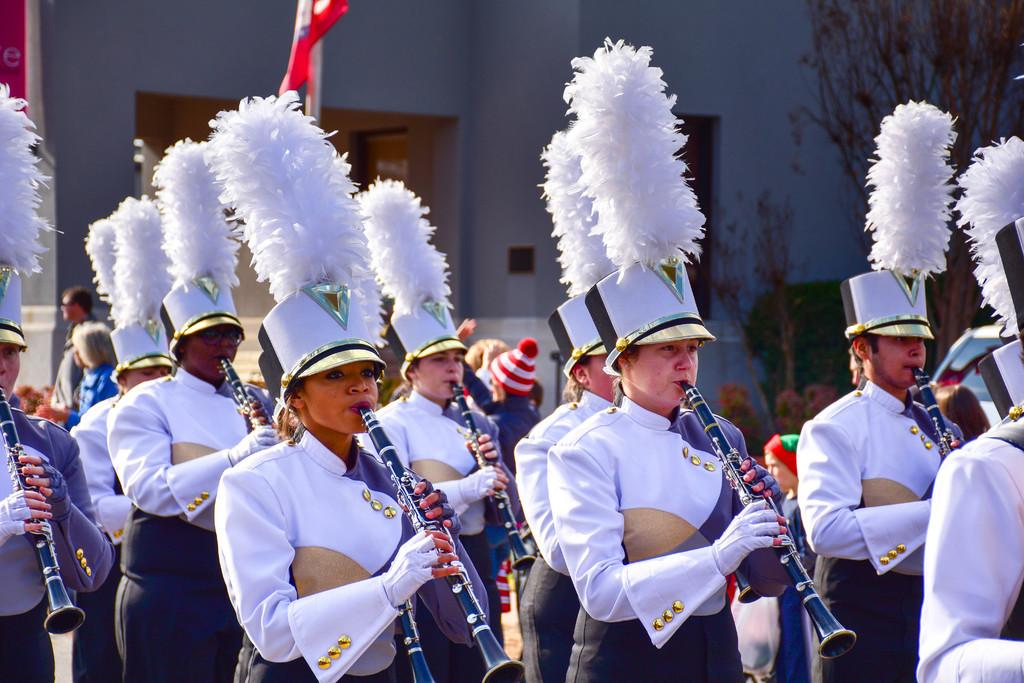Who or what can be seen in the image? There are people in the image. What are the people doing in the image? The people are standing and holding musical instruments. What type of headwear are the people wearing? The people are wearing feather caps. What type of locket can be seen hanging from the feather cap of one of the people in the image? There is no locket visible on any of the feather caps in the image. 